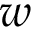Convert formula to latex. <formula><loc_0><loc_0><loc_500><loc_500>w</formula> 